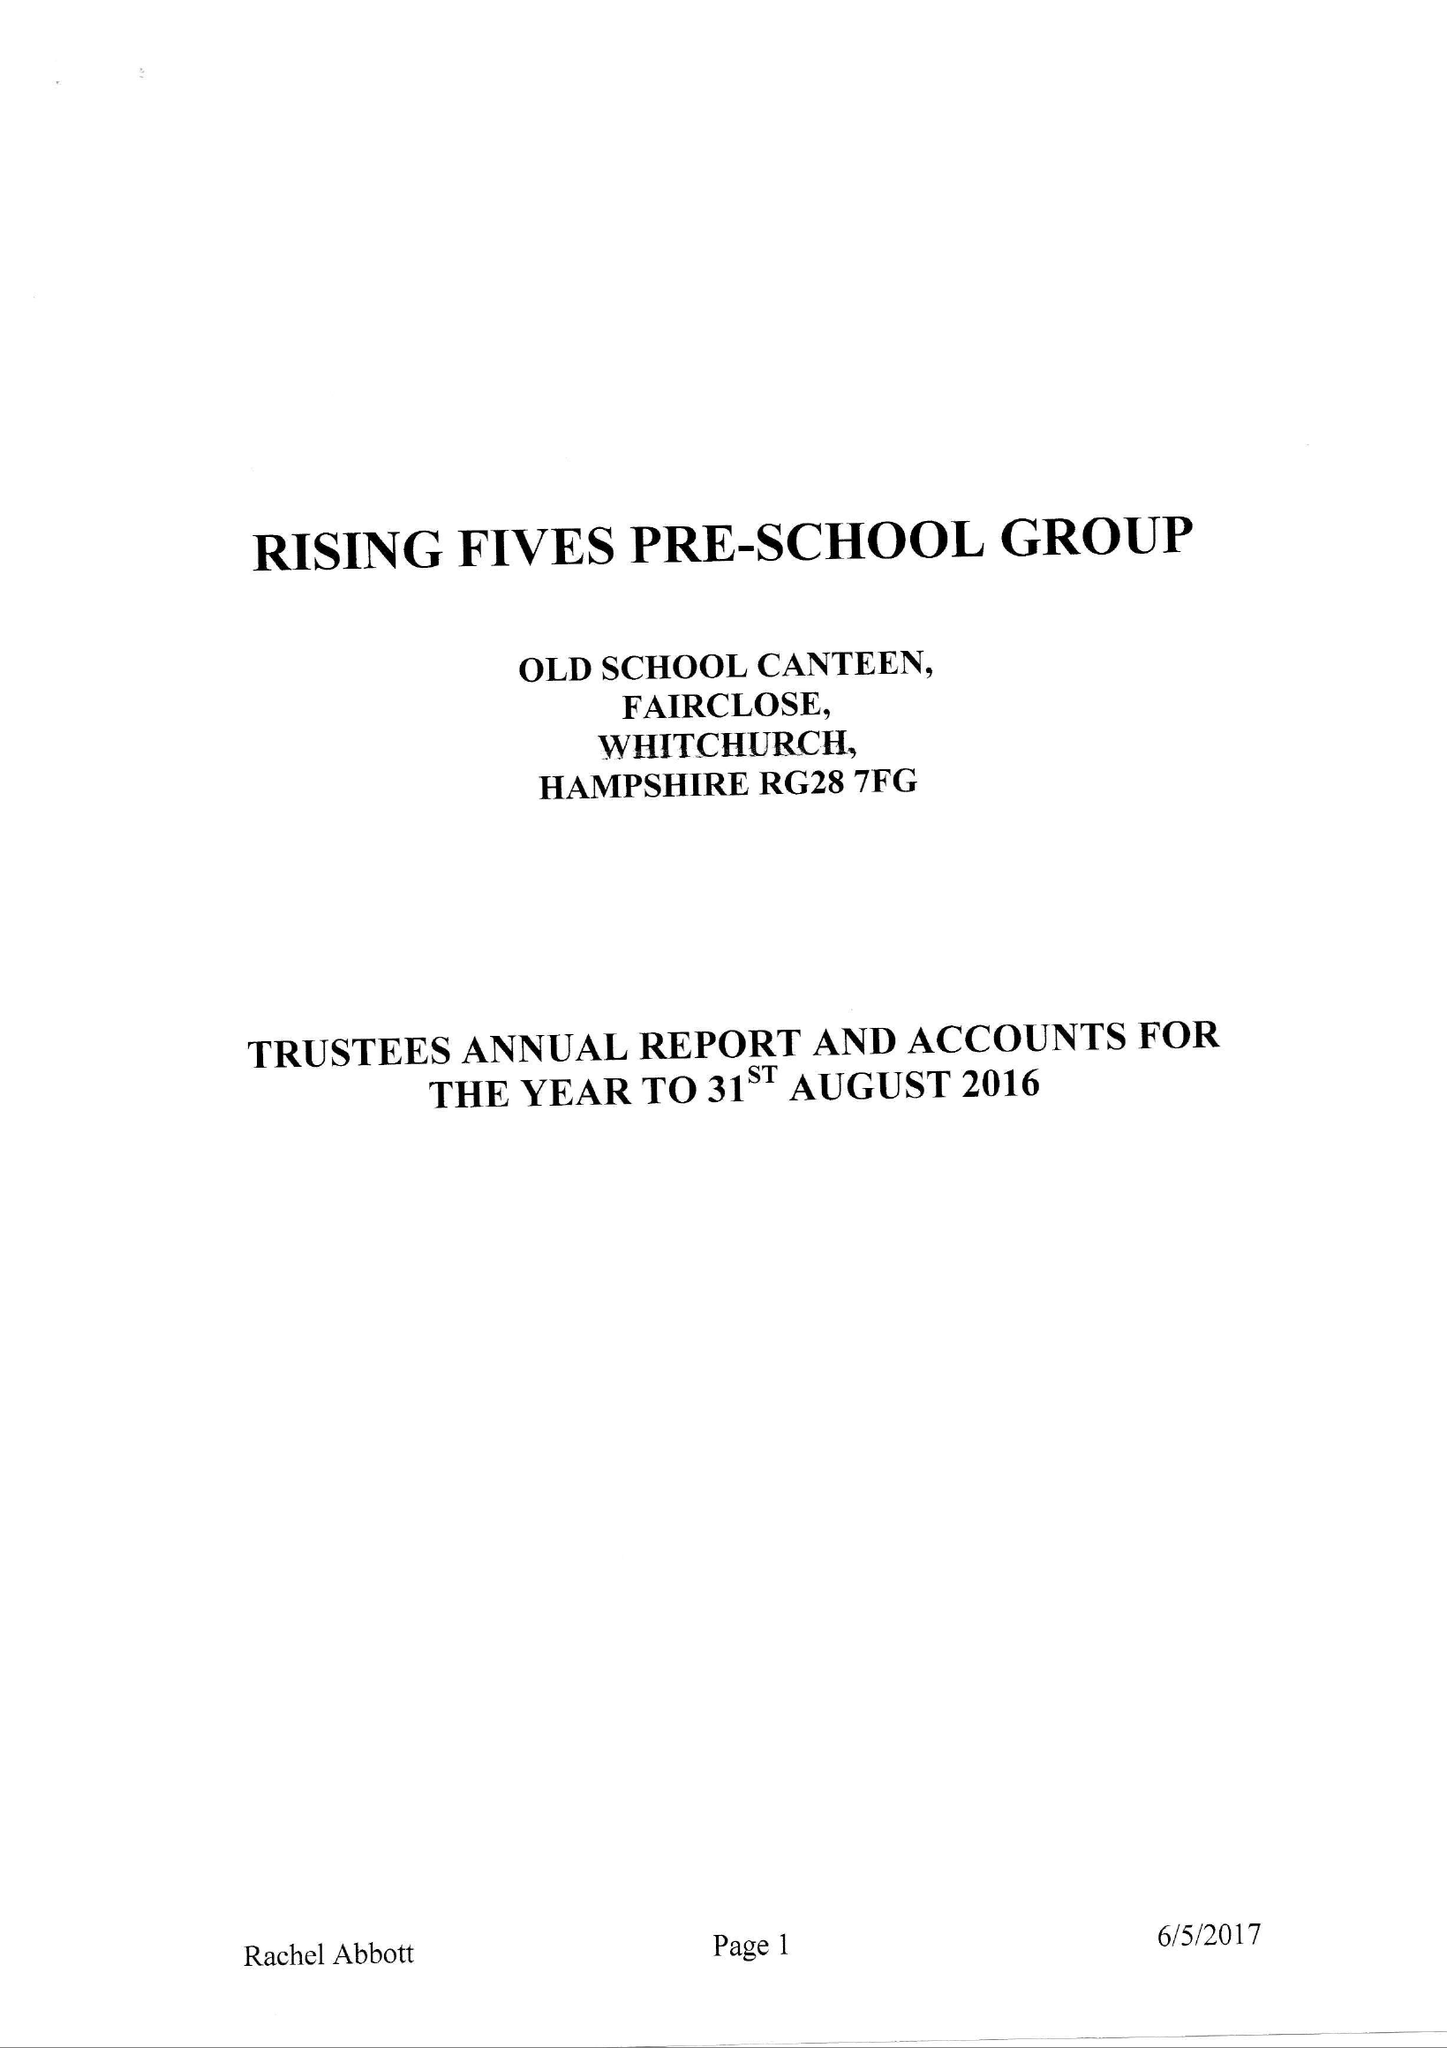What is the value for the income_annually_in_british_pounds?
Answer the question using a single word or phrase. 91143.00 